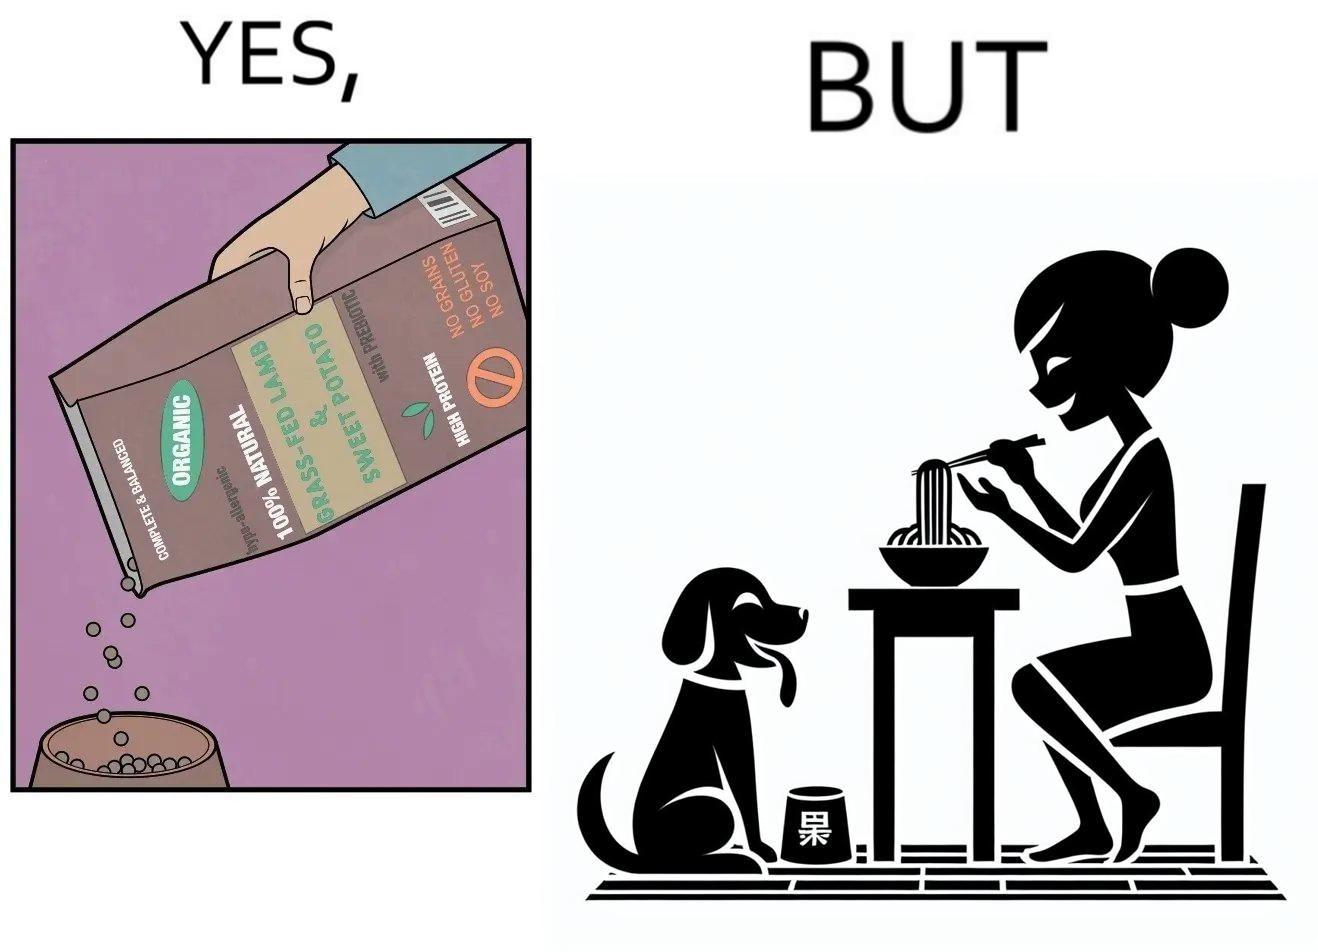Describe the satirical element in this image. The image is funny because while the food for the dog that the woman pours is well balanced, the food that she herself is eating is bad for her health. 